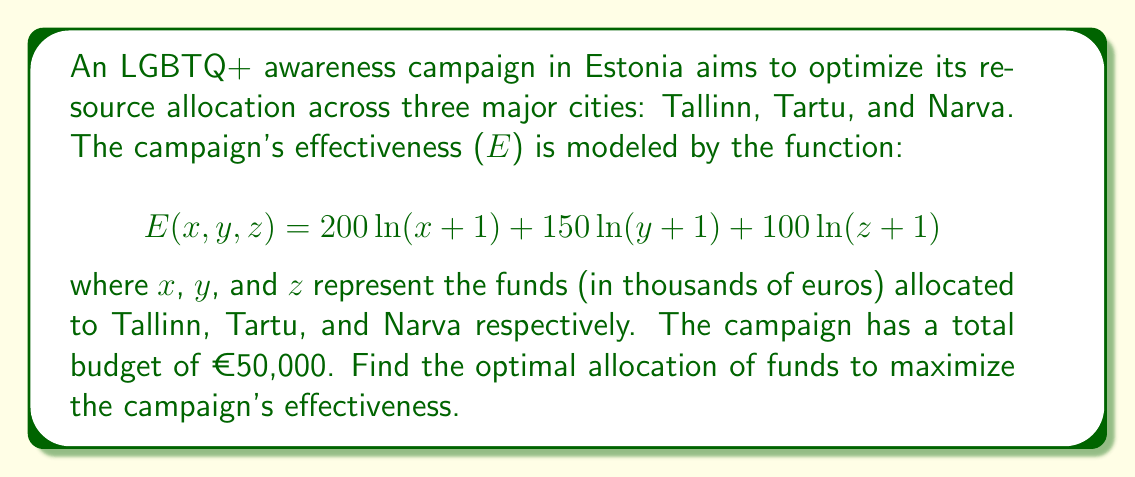Can you solve this math problem? To solve this optimization problem, we'll use the method of Lagrange multipliers.

1) First, we set up the constraint equation:
   $$g(x,y,z) = x + y + z - 50 = 0$$

2) Now, we form the Lagrangian function:
   $$L(x,y,z,\lambda) = 200\ln(x+1) + 150\ln(y+1) + 100\ln(z+1) - \lambda(x + y + z - 50)$$

3) We calculate the partial derivatives and set them equal to zero:

   $$\frac{\partial L}{\partial x} = \frac{200}{x+1} - \lambda = 0$$
   $$\frac{\partial L}{\partial y} = \frac{150}{y+1} - \lambda = 0$$
   $$\frac{\partial L}{\partial z} = \frac{100}{z+1} - \lambda = 0$$
   $$\frac{\partial L}{\partial \lambda} = x + y + z - 50 = 0$$

4) From the first three equations:
   $$x = \frac{200}{\lambda} - 1$$
   $$y = \frac{150}{\lambda} - 1$$
   $$z = \frac{100}{\lambda} - 1$$

5) Substituting these into the constraint equation:
   $$(\frac{200}{\lambda} - 1) + (\frac{150}{\lambda} - 1) + (\frac{100}{\lambda} - 1) = 50$$
   $$\frac{450}{\lambda} - 3 = 50$$
   $$\frac{450}{\lambda} = 53$$
   $$\lambda = \frac{450}{53}$$

6) Now we can solve for x, y, and z:
   $$x = \frac{200}{\frac{450}{53}} - 1 = \frac{10600}{450} - 1 \approx 22.56$$
   $$y = \frac{150}{\frac{450}{53}} - 1 = \frac{7950}{450} - 1 \approx 16.67$$
   $$z = \frac{100}{\frac{450}{53}} - 1 = \frac{5300}{450} - 1 \approx 10.78$$

7) Rounding to the nearest thousand euros (as per the question setup):
   x ≈ 23, y ≈ 17, z ≈ 10
Answer: The optimal allocation of funds to maximize the campaign's effectiveness is approximately €23,000 for Tallinn, €17,000 for Tartu, and €10,000 for Narva. 